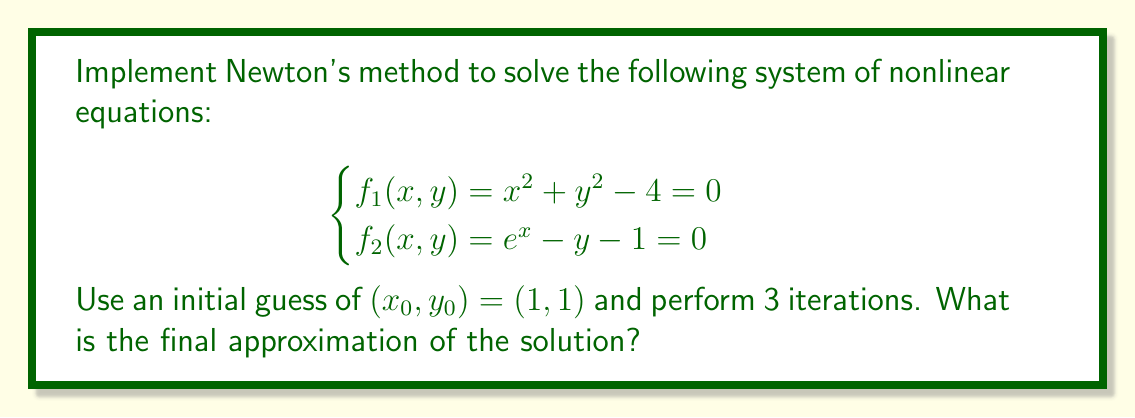Show me your answer to this math problem. To solve this system using Newton's method, we'll follow these steps:

1. Define the system of equations:
   $$F(x, y) = \begin{bmatrix} f_1(x, y) \\ f_2(x, y) \end{bmatrix} = \begin{bmatrix} x^2 + y^2 - 4 \\ e^x - y - 1 \end{bmatrix}$$

2. Calculate the Jacobian matrix:
   $$J(x, y) = \begin{bmatrix} 
   \frac{\partial f_1}{\partial x} & \frac{\partial f_1}{\partial y} \\
   \frac{\partial f_2}{\partial x} & \frac{\partial f_2}{\partial y}
   \end{bmatrix} = \begin{bmatrix}
   2x & 2y \\
   e^x & -1
   \end{bmatrix}$$

3. Implement Newton's method iteration:
   $$(x_{n+1}, y_{n+1}) = (x_n, y_n) - J(x_n, y_n)^{-1} F(x_n, y_n)$$

4. Perform 3 iterations:

   Iteration 1:
   $$F(1, 1) = \begin{bmatrix} 1^2 + 1^2 - 4 \\ e^1 - 1 - 1 \end{bmatrix} = \begin{bmatrix} -2 \\ 0.71828 \end{bmatrix}$$
   $$J(1, 1) = \begin{bmatrix} 2 & 2 \\ e & -1 \end{bmatrix}$$
   $$J(1, 1)^{-1} = \frac{1}{2+2e} \begin{bmatrix} -1 & -2 \\ -e & 2 \end{bmatrix}$$
   $$(x_1, y_1) = (1, 1) - \frac{1}{2+2e} \begin{bmatrix} -1 & -2 \\ -e & 2 \end{bmatrix} \begin{bmatrix} -2 \\ 0.71828 \end{bmatrix} \approx (1.5652, 1.2433)$$

   Iteration 2:
   $$F(1.5652, 1.2433) \approx \begin{bmatrix} 0.0085 \\ 0.0399 \end{bmatrix}$$
   $$J(1.5652, 1.2433) \approx \begin{bmatrix} 3.1304 & 2.4866 \\ 4.7833 & -1 \end{bmatrix}$$
   $$(x_2, y_2) \approx (1.5434, 1.2642)$$

   Iteration 3:
   $$F(1.5434, 1.2642) \approx \begin{bmatrix} 0.0001 \\ 0.0005 \end{bmatrix}$$
   $$J(1.5434, 1.2642) \approx \begin{bmatrix} 3.0868 & 2.5284 \\ 4.6803 & -1 \end{bmatrix}$$
   $$(x_3, y_3) \approx (1.5431, 1.2649)$$

The final approximation after 3 iterations is $(x_3, y_3) \approx (1.5431, 1.2649)$.
Answer: $(1.5431, 1.2649)$ 